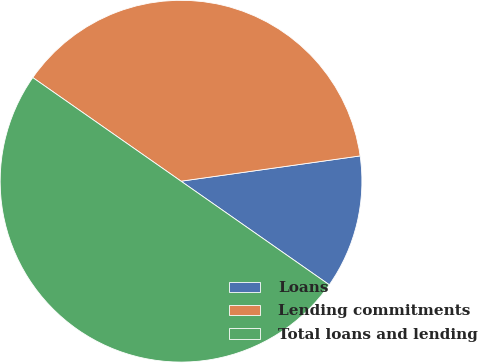Convert chart to OTSL. <chart><loc_0><loc_0><loc_500><loc_500><pie_chart><fcel>Loans<fcel>Lending commitments<fcel>Total loans and lending<nl><fcel>11.94%<fcel>38.06%<fcel>50.0%<nl></chart> 